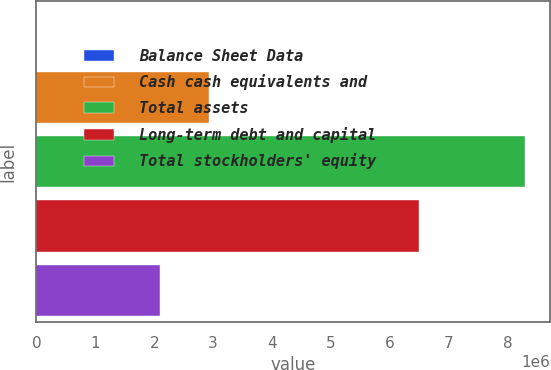Convert chart to OTSL. <chart><loc_0><loc_0><loc_500><loc_500><bar_chart><fcel>Balance Sheet Data<fcel>Cash cash equivalents and<fcel>Total assets<fcel>Long-term debt and capital<fcel>Total stockholders' equity<nl><fcel>2009<fcel>2.92102e+06<fcel>8.29534e+06<fcel>6.49656e+06<fcel>2.09169e+06<nl></chart> 